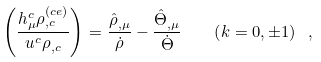Convert formula to latex. <formula><loc_0><loc_0><loc_500><loc_500>\left ( \frac { h ^ { c } _ { \mu } \rho _ { , c } ^ { \left ( c e \right ) } } { u ^ { c } \rho _ { , c } } \right ) ^ { } = \frac { \hat { \rho } _ { , \mu } } { \dot { \rho } } - \frac { \hat { \Theta } _ { , \mu } } { \dot { \Theta } } \quad \left ( k = 0 , \pm 1 \right ) \ ,</formula> 